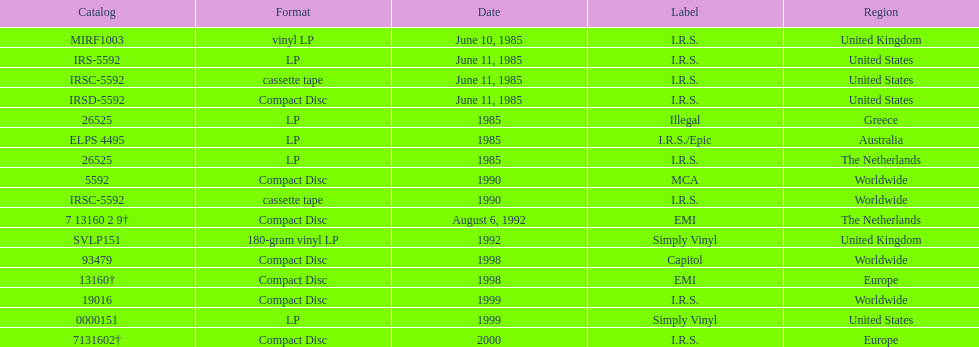Which year had the most releases? 1985. 